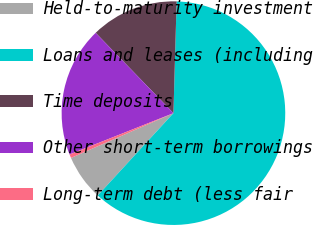Convert chart to OTSL. <chart><loc_0><loc_0><loc_500><loc_500><pie_chart><fcel>Held-to-maturity investment<fcel>Loans and leases (including<fcel>Time deposits<fcel>Other short-term borrowings<fcel>Long-term debt (less fair<nl><fcel>6.61%<fcel>61.37%<fcel>12.7%<fcel>18.78%<fcel>0.53%<nl></chart> 